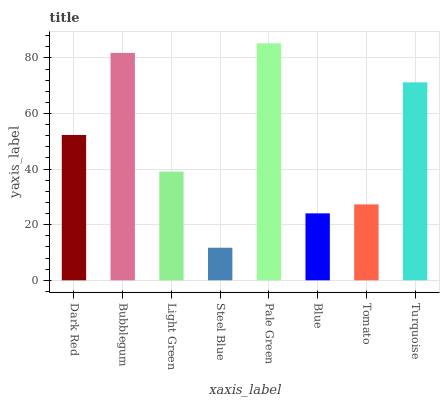Is Steel Blue the minimum?
Answer yes or no. Yes. Is Pale Green the maximum?
Answer yes or no. Yes. Is Bubblegum the minimum?
Answer yes or no. No. Is Bubblegum the maximum?
Answer yes or no. No. Is Bubblegum greater than Dark Red?
Answer yes or no. Yes. Is Dark Red less than Bubblegum?
Answer yes or no. Yes. Is Dark Red greater than Bubblegum?
Answer yes or no. No. Is Bubblegum less than Dark Red?
Answer yes or no. No. Is Dark Red the high median?
Answer yes or no. Yes. Is Light Green the low median?
Answer yes or no. Yes. Is Turquoise the high median?
Answer yes or no. No. Is Blue the low median?
Answer yes or no. No. 